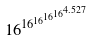<formula> <loc_0><loc_0><loc_500><loc_500>1 6 ^ { 1 6 ^ { 1 6 ^ { 1 6 ^ { 1 6 ^ { 4 . 5 2 7 } } } } }</formula> 